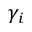<formula> <loc_0><loc_0><loc_500><loc_500>\gamma _ { i }</formula> 